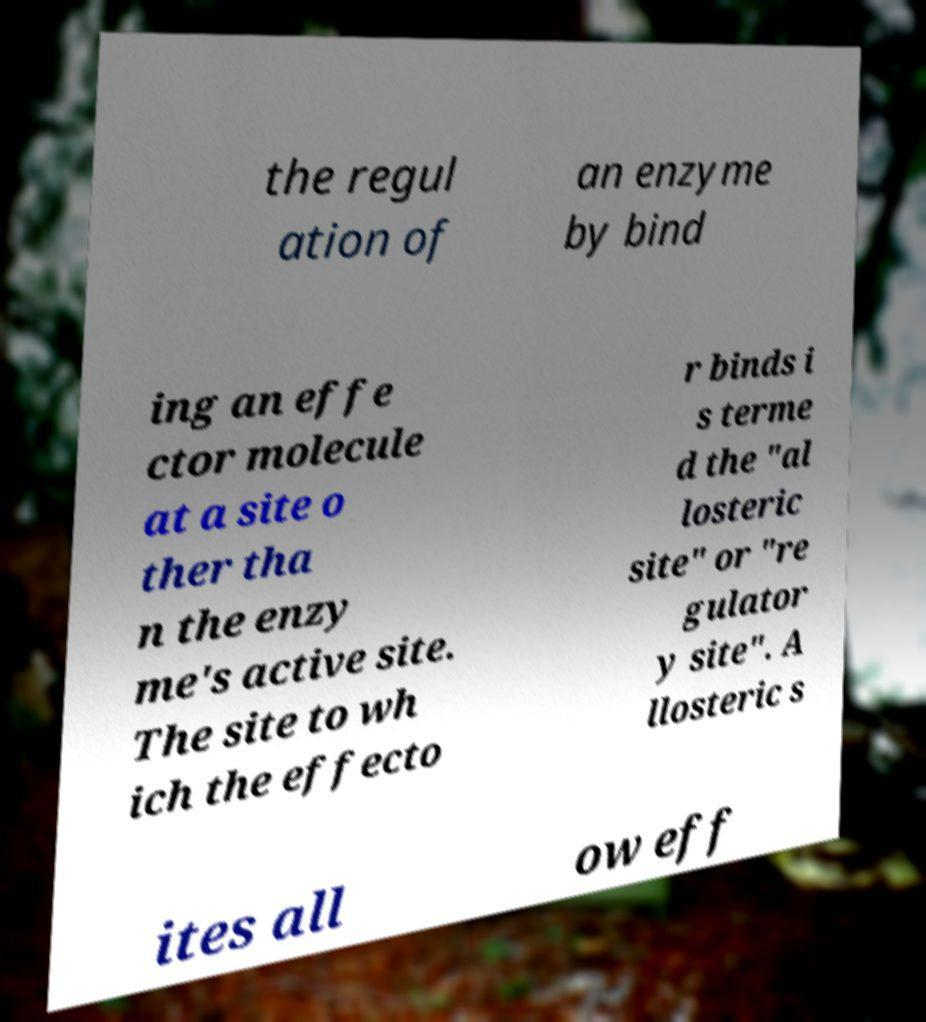What messages or text are displayed in this image? I need them in a readable, typed format. the regul ation of an enzyme by bind ing an effe ctor molecule at a site o ther tha n the enzy me's active site. The site to wh ich the effecto r binds i s terme d the "al losteric site" or "re gulator y site". A llosteric s ites all ow eff 